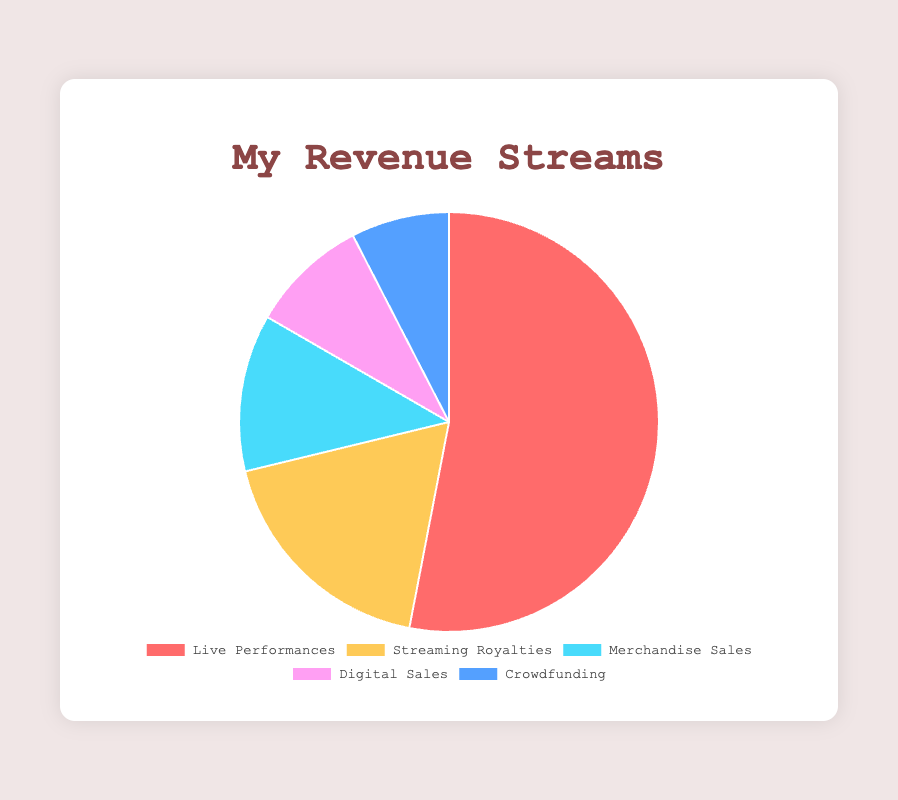What is the total revenue from Live Performances and Crowdfunding? First, identify the revenue from Live Performances ($35,000) and Crowdfunding ($5,000). Then, sum these amounts: $35,000 + $5,000 = $40,000
Answer: $40,000 Which revenue stream contributes the most to the total revenue? Identify the contribution of each revenue stream and compare their values. The highest value is Live Performances which is $35,000
Answer: Live Performances Which revenue stream has the smallest contribution? Identify the contribution of each stream and find the smallest value. The revenue from Crowdfunding is $5,000, which is the smallest
Answer: Crowdfunding By how much do Live Performances exceed Streaming Royalties in revenue? Subtract the revenue of Streaming Royalties ($12,000) from Live Performances ($35,000). $35,000 - $12,000 = $23,000
Answer: $23,000 What is the average revenue generated by the five streams? Sum up all revenue values: $35,000 + $12,000 + $8,000 + $6,000 + $5,000 = $66,000. Then, divide by the number of streams (5). $66,000 / 5 = $13,200
Answer: $13,200 Which revenue stream is represented by the yellow color segment in the pie chart? The yellow segment corresponds to Streaming Royalties in the provided color scheme
Answer: Streaming Royalties What percentage of the total revenue comes from Merchandise Sales? Calculate the total revenue first: $66,000. The revenue from Merchandise Sales is $8,000. Then, find the percentage: ($8,000 / $66,000) * 100 ≈ 12.12%
Answer: 12.12% 